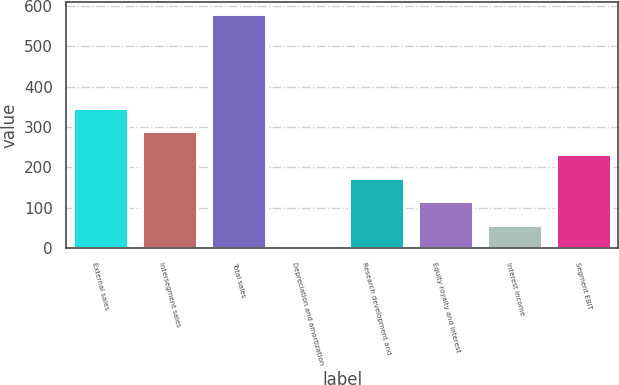Convert chart to OTSL. <chart><loc_0><loc_0><loc_500><loc_500><bar_chart><fcel>External sales<fcel>Intersegment sales<fcel>Total sales<fcel>Depreciation and amortization<fcel>Research development and<fcel>Equity royalty and interest<fcel>Interest income<fcel>Segment EBIT<nl><fcel>347.8<fcel>290<fcel>579<fcel>1<fcel>174.4<fcel>116.6<fcel>58.8<fcel>232.2<nl></chart> 